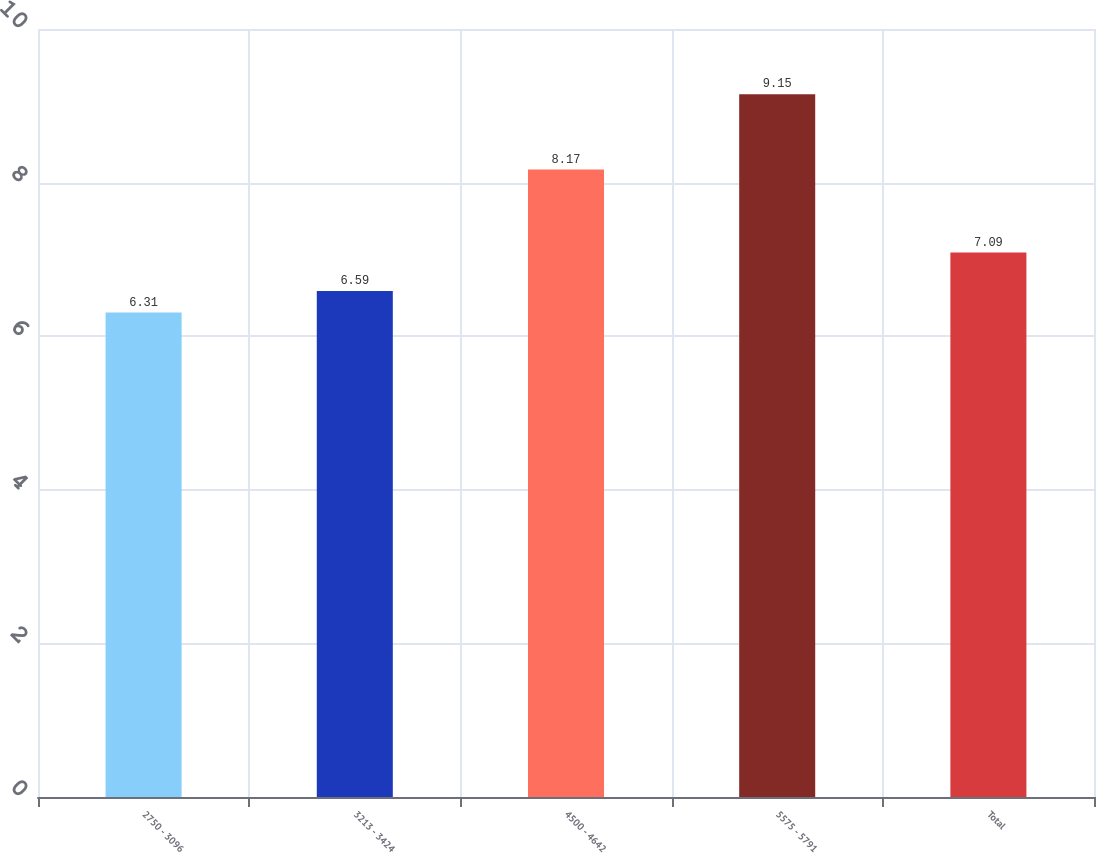<chart> <loc_0><loc_0><loc_500><loc_500><bar_chart><fcel>2750 - 3096<fcel>3213 - 3424<fcel>4500 - 4642<fcel>5575 - 5791<fcel>Total<nl><fcel>6.31<fcel>6.59<fcel>8.17<fcel>9.15<fcel>7.09<nl></chart> 